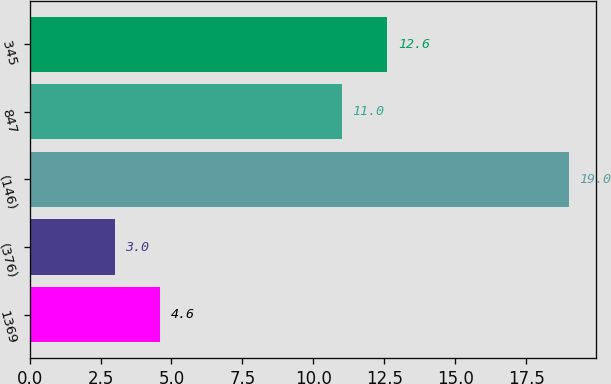<chart> <loc_0><loc_0><loc_500><loc_500><bar_chart><fcel>1369<fcel>(376)<fcel>(146)<fcel>847<fcel>345<nl><fcel>4.6<fcel>3<fcel>19<fcel>11<fcel>12.6<nl></chart> 